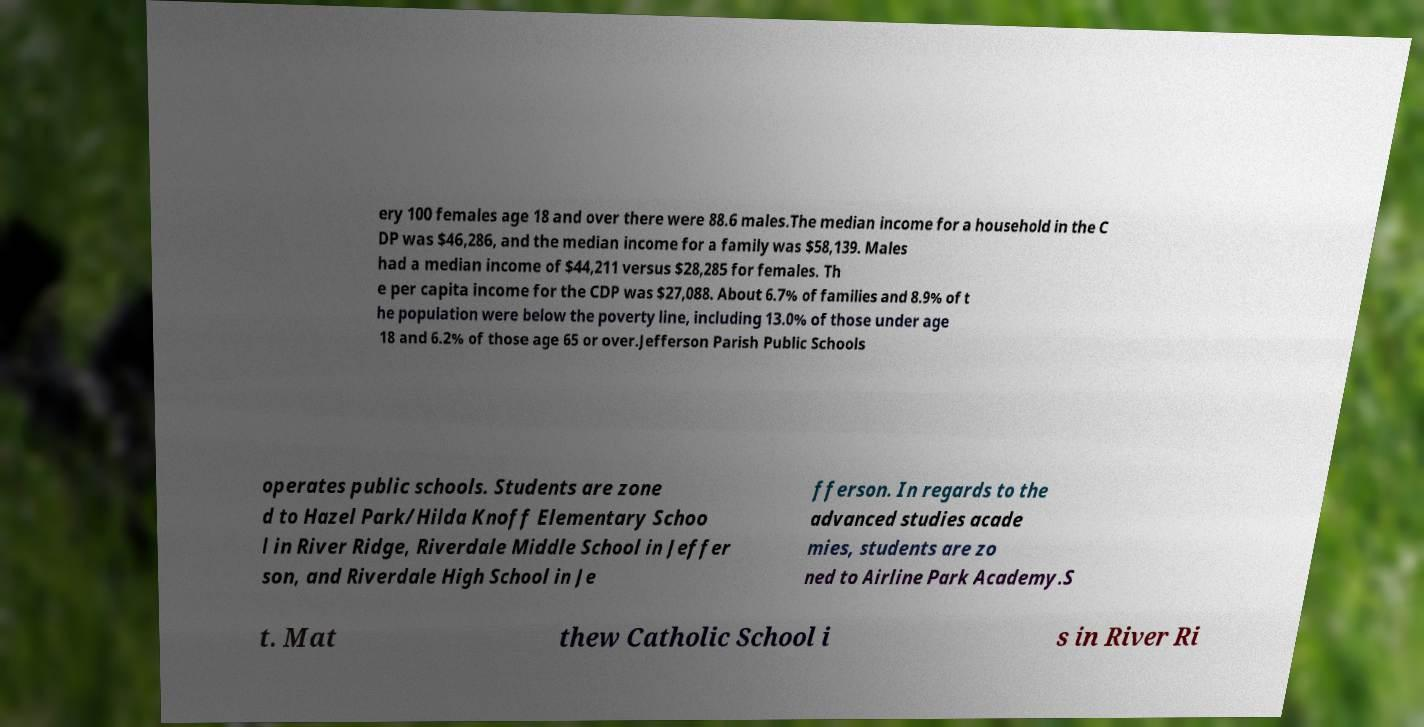For documentation purposes, I need the text within this image transcribed. Could you provide that? ery 100 females age 18 and over there were 88.6 males.The median income for a household in the C DP was $46,286, and the median income for a family was $58,139. Males had a median income of $44,211 versus $28,285 for females. Th e per capita income for the CDP was $27,088. About 6.7% of families and 8.9% of t he population were below the poverty line, including 13.0% of those under age 18 and 6.2% of those age 65 or over.Jefferson Parish Public Schools operates public schools. Students are zone d to Hazel Park/Hilda Knoff Elementary Schoo l in River Ridge, Riverdale Middle School in Jeffer son, and Riverdale High School in Je fferson. In regards to the advanced studies acade mies, students are zo ned to Airline Park Academy.S t. Mat thew Catholic School i s in River Ri 